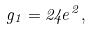Convert formula to latex. <formula><loc_0><loc_0><loc_500><loc_500>g _ { 1 } = 2 4 e ^ { 2 } ,</formula> 